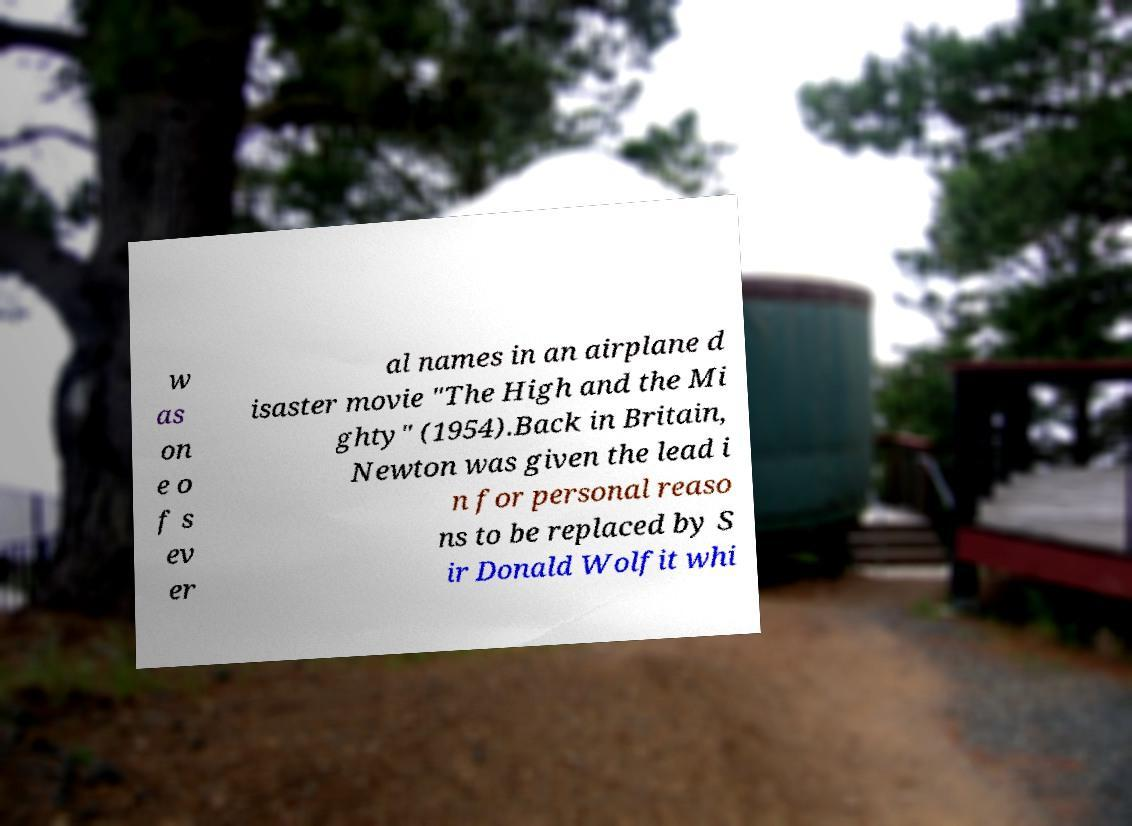Can you read and provide the text displayed in the image?This photo seems to have some interesting text. Can you extract and type it out for me? w as on e o f s ev er al names in an airplane d isaster movie "The High and the Mi ghty" (1954).Back in Britain, Newton was given the lead i n for personal reaso ns to be replaced by S ir Donald Wolfit whi 